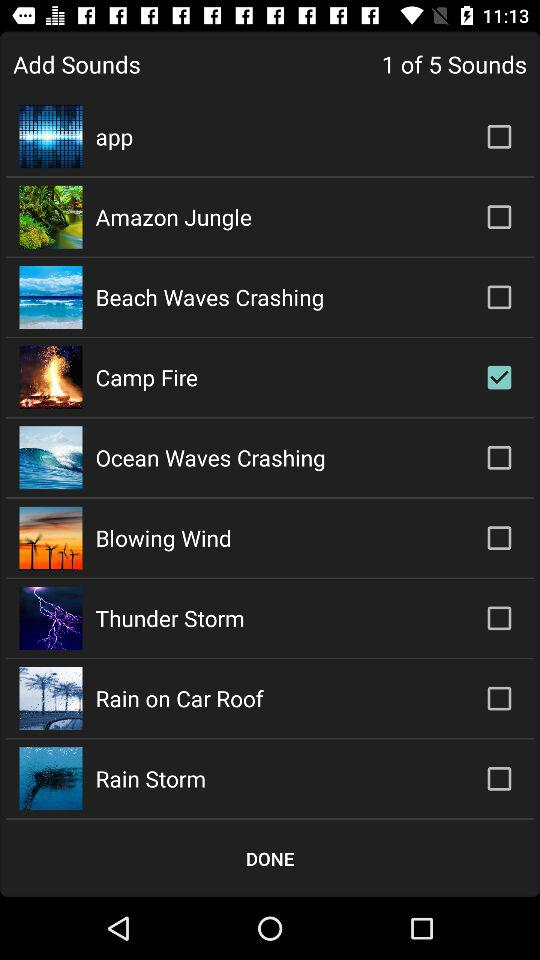What's the total number of sounds that can be added? You can add a total of five sounds. 